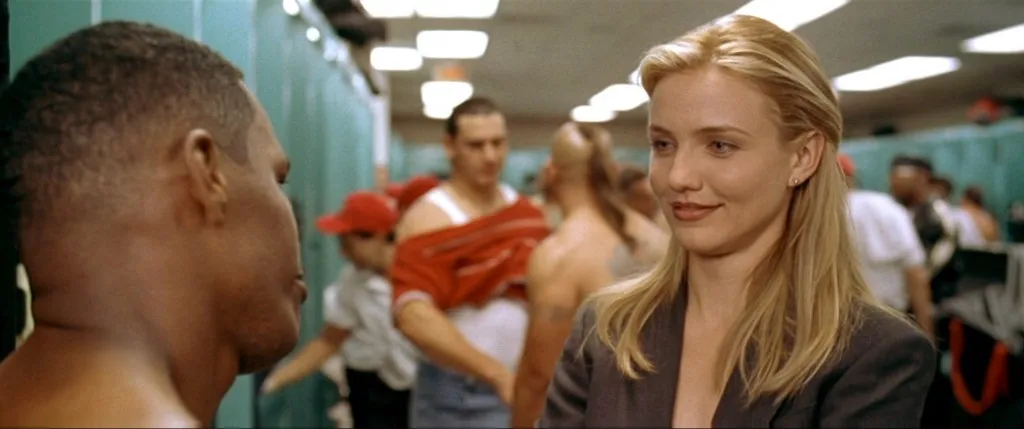Explain the visual content of the image in great detail. The image depicts a scene inside what appears to be a sports locker room. On the right, a woman with blonde hair, wearing a dark blazer and a neutral expression, is looking intently at a shirtless man on the left. This man has his profile to the camera, revealing a focused or possibly concerned expression. There is a hint of another individual behind the woman, and the blurred background suggests movement, indicating that there are other people present, like players or staff, within the locker room. Details like the lockers, hanging towels, and sports gear add to the authenticity of this environment. 